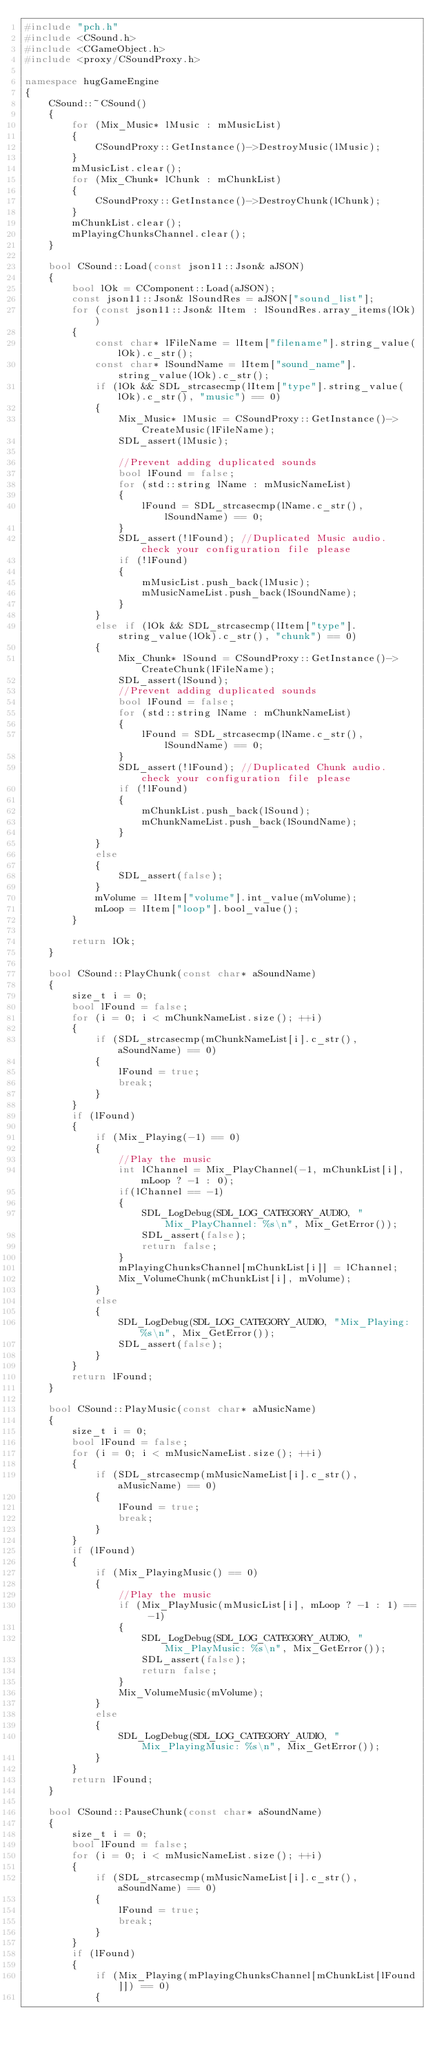<code> <loc_0><loc_0><loc_500><loc_500><_C++_>#include "pch.h"
#include <CSound.h>
#include <CGameObject.h>
#include <proxy/CSoundProxy.h>

namespace hugGameEngine
{
    CSound::~CSound()
    {
        for (Mix_Music* lMusic : mMusicList)
        {
            CSoundProxy::GetInstance()->DestroyMusic(lMusic);
        }
        mMusicList.clear();
        for (Mix_Chunk* lChunk : mChunkList)
        {
            CSoundProxy::GetInstance()->DestroyChunk(lChunk);
        }
        mChunkList.clear();
        mPlayingChunksChannel.clear();
    }

    bool CSound::Load(const json11::Json& aJSON)
    {
        bool lOk = CComponent::Load(aJSON);
        const json11::Json& lSoundRes = aJSON["sound_list"];
        for (const json11::Json& lItem : lSoundRes.array_items(lOk))
        {
            const char* lFileName = lItem["filename"].string_value(lOk).c_str();
            const char* lSoundName = lItem["sound_name"].string_value(lOk).c_str();
            if (lOk && SDL_strcasecmp(lItem["type"].string_value(lOk).c_str(), "music") == 0)
            {
                Mix_Music* lMusic = CSoundProxy::GetInstance()->CreateMusic(lFileName);
                SDL_assert(lMusic);

                //Prevent adding duplicated sounds
                bool lFound = false;
                for (std::string lName : mMusicNameList)
                {
                    lFound = SDL_strcasecmp(lName.c_str(), lSoundName) == 0;
                }
                SDL_assert(!lFound); //Duplicated Music audio. check your configuration file please
                if (!lFound)
                {
                    mMusicList.push_back(lMusic);
                    mMusicNameList.push_back(lSoundName);
                }
            }
            else if (lOk && SDL_strcasecmp(lItem["type"].string_value(lOk).c_str(), "chunk") == 0)
            {
                Mix_Chunk* lSound = CSoundProxy::GetInstance()->CreateChunk(lFileName);
                SDL_assert(lSound);
                //Prevent adding duplicated sounds
                bool lFound = false;
                for (std::string lName : mChunkNameList)
                {
                    lFound = SDL_strcasecmp(lName.c_str(), lSoundName) == 0;
                }
                SDL_assert(!lFound); //Duplicated Chunk audio. check your configuration file please
                if (!lFound)
                {
                    mChunkList.push_back(lSound);
                    mChunkNameList.push_back(lSoundName);
                }
            }
            else
            {
                SDL_assert(false);
            }
            mVolume = lItem["volume"].int_value(mVolume);
            mLoop = lItem["loop"].bool_value();
        }
        
        return lOk;
    }

    bool CSound::PlayChunk(const char* aSoundName)
    {
        size_t i = 0;
        bool lFound = false;
        for (i = 0; i < mChunkNameList.size(); ++i)
        {
            if (SDL_strcasecmp(mChunkNameList[i].c_str(), aSoundName) == 0)
            {
                lFound = true;
                break;
            }
        }
        if (lFound)
        {
            if (Mix_Playing(-1) == 0)
            {
                //Play the music
                int lChannel = Mix_PlayChannel(-1, mChunkList[i], mLoop ? -1 : 0);
                if(lChannel == -1)
                {
                    SDL_LogDebug(SDL_LOG_CATEGORY_AUDIO, "Mix_PlayChannel: %s\n", Mix_GetError());
                    SDL_assert(false);
                    return false;
                }
                mPlayingChunksChannel[mChunkList[i]] = lChannel;
                Mix_VolumeChunk(mChunkList[i], mVolume);
            }
            else
            {
                SDL_LogDebug(SDL_LOG_CATEGORY_AUDIO, "Mix_Playing: %s\n", Mix_GetError());
                SDL_assert(false);
            }
        }
        return lFound;
    }

    bool CSound::PlayMusic(const char* aMusicName)
    {
        size_t i = 0;
        bool lFound = false;
        for (i = 0; i < mMusicNameList.size(); ++i)
        {
            if (SDL_strcasecmp(mMusicNameList[i].c_str(), aMusicName) == 0)
            {
                lFound = true;
                break;
            }
        }
        if (lFound)
        {
            if (Mix_PlayingMusic() == 0)
            {
                //Play the music
                if (Mix_PlayMusic(mMusicList[i], mLoop ? -1 : 1) == -1)
                {
                    SDL_LogDebug(SDL_LOG_CATEGORY_AUDIO, "Mix_PlayMusic: %s\n", Mix_GetError());
                    SDL_assert(false);
                    return false;
                }
                Mix_VolumeMusic(mVolume);
            }
            else
            {
                SDL_LogDebug(SDL_LOG_CATEGORY_AUDIO, "Mix_PlayingMusic: %s\n", Mix_GetError());
            }
        }
        return lFound;
    }

    bool CSound::PauseChunk(const char* aSoundName)
    {
        size_t i = 0;
        bool lFound = false;
        for (i = 0; i < mMusicNameList.size(); ++i)
        {
            if (SDL_strcasecmp(mMusicNameList[i].c_str(), aSoundName) == 0)
            {
                lFound = true;
                break;
            }
        }
        if (lFound)
        {
            if (Mix_Playing(mPlayingChunksChannel[mChunkList[lFound]]) == 0)
            {</code> 